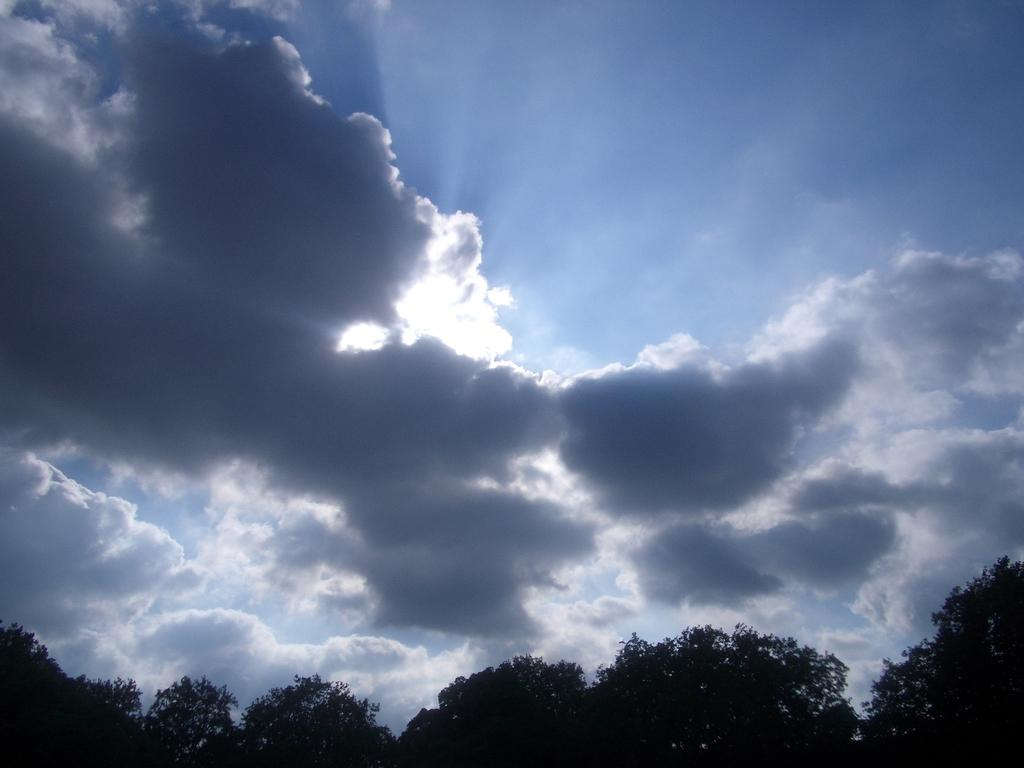What type of vegetation can be seen in the image? There are trees in the image. What part of the natural environment is visible in the image? The sky is visible in the image. What type of doll can be seen locked inside the church in the image? There is no doll, lock, or church present in the image. 